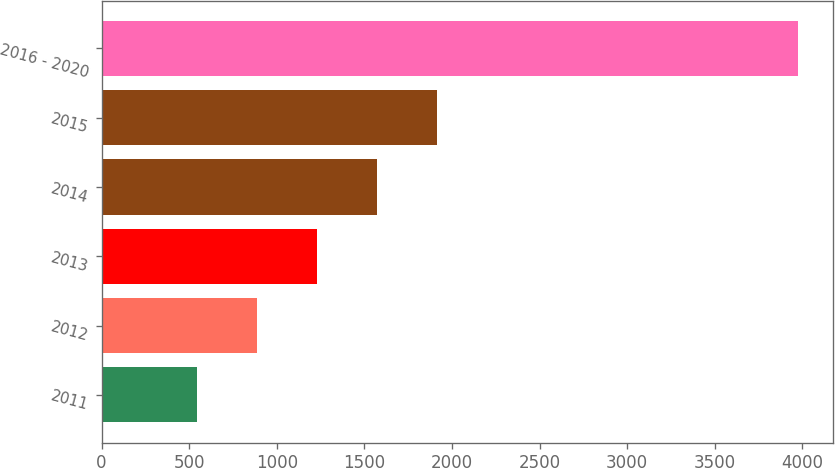Convert chart to OTSL. <chart><loc_0><loc_0><loc_500><loc_500><bar_chart><fcel>2011<fcel>2012<fcel>2013<fcel>2014<fcel>2015<fcel>2016 - 2020<nl><fcel>545<fcel>887.9<fcel>1230.8<fcel>1573.7<fcel>1916.6<fcel>3974<nl></chart> 